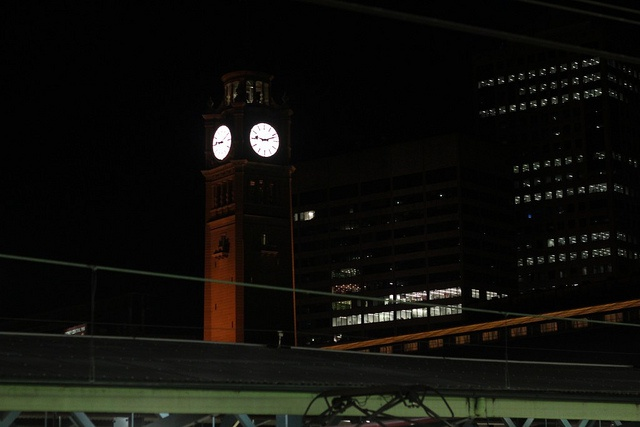Describe the objects in this image and their specific colors. I can see clock in black, white, darkgray, and pink tones and clock in black, white, darkgray, pink, and gray tones in this image. 